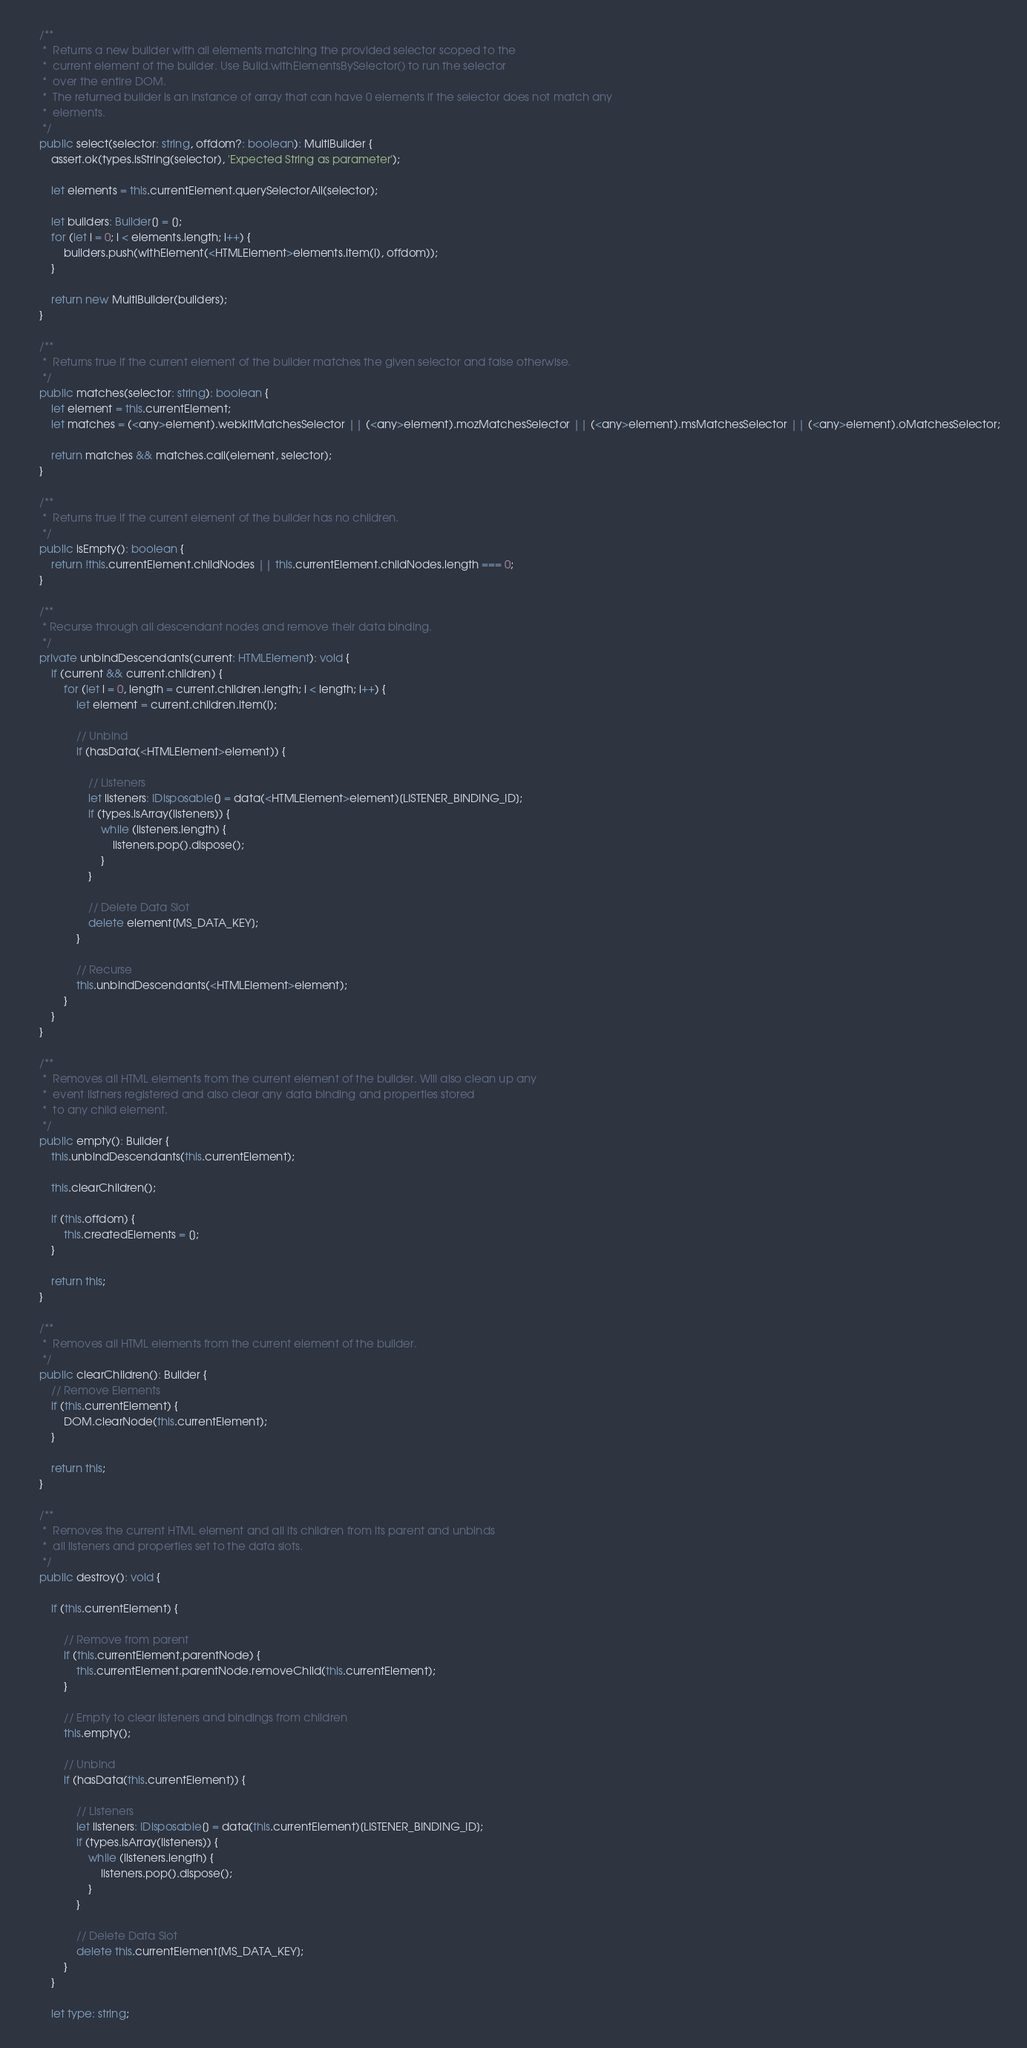<code> <loc_0><loc_0><loc_500><loc_500><_TypeScript_>
	/**
	 *  Returns a new builder with all elements matching the provided selector scoped to the
	 *  current element of the builder. Use Build.withElementsBySelector() to run the selector
	 *  over the entire DOM.
	 *  The returned builder is an instance of array that can have 0 elements if the selector does not match any
	 *  elements.
	 */
	public select(selector: string, offdom?: boolean): MultiBuilder {
		assert.ok(types.isString(selector), 'Expected String as parameter');

		let elements = this.currentElement.querySelectorAll(selector);

		let builders: Builder[] = [];
		for (let i = 0; i < elements.length; i++) {
			builders.push(withElement(<HTMLElement>elements.item(i), offdom));
		}

		return new MultiBuilder(builders);
	}

	/**
	 *  Returns true if the current element of the builder matches the given selector and false otherwise.
	 */
	public matches(selector: string): boolean {
		let element = this.currentElement;
		let matches = (<any>element).webkitMatchesSelector || (<any>element).mozMatchesSelector || (<any>element).msMatchesSelector || (<any>element).oMatchesSelector;

		return matches && matches.call(element, selector);
	}

	/**
	 *  Returns true if the current element of the builder has no children.
	 */
	public isEmpty(): boolean {
		return !this.currentElement.childNodes || this.currentElement.childNodes.length === 0;
	}

	/**
	 * Recurse through all descendant nodes and remove their data binding.
	 */
	private unbindDescendants(current: HTMLElement): void {
		if (current && current.children) {
			for (let i = 0, length = current.children.length; i < length; i++) {
				let element = current.children.item(i);

				// Unbind
				if (hasData(<HTMLElement>element)) {

					// Listeners
					let listeners: IDisposable[] = data(<HTMLElement>element)[LISTENER_BINDING_ID];
					if (types.isArray(listeners)) {
						while (listeners.length) {
							listeners.pop().dispose();
						}
					}

					// Delete Data Slot
					delete element[MS_DATA_KEY];
				}

				// Recurse
				this.unbindDescendants(<HTMLElement>element);
			}
		}
	}

	/**
	 *  Removes all HTML elements from the current element of the builder. Will also clean up any
	 *  event listners registered and also clear any data binding and properties stored
	 *  to any child element.
	 */
	public empty(): Builder {
		this.unbindDescendants(this.currentElement);

		this.clearChildren();

		if (this.offdom) {
			this.createdElements = [];
		}

		return this;
	}

	/**
	 *  Removes all HTML elements from the current element of the builder.
	 */
	public clearChildren(): Builder {
		// Remove Elements
		if (this.currentElement) {
			DOM.clearNode(this.currentElement);
		}

		return this;
	}

	/**
	 *  Removes the current HTML element and all its children from its parent and unbinds
	 *  all listeners and properties set to the data slots.
	 */
	public destroy(): void {

		if (this.currentElement) {

			// Remove from parent
			if (this.currentElement.parentNode) {
				this.currentElement.parentNode.removeChild(this.currentElement);
			}

			// Empty to clear listeners and bindings from children
			this.empty();

			// Unbind
			if (hasData(this.currentElement)) {

				// Listeners
				let listeners: IDisposable[] = data(this.currentElement)[LISTENER_BINDING_ID];
				if (types.isArray(listeners)) {
					while (listeners.length) {
						listeners.pop().dispose();
					}
				}

				// Delete Data Slot
				delete this.currentElement[MS_DATA_KEY];
			}
		}

		let type: string;
</code> 